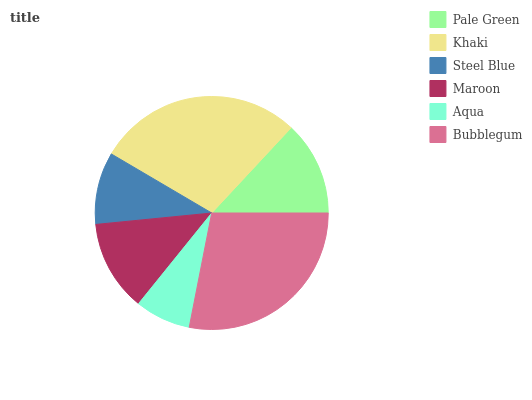Is Aqua the minimum?
Answer yes or no. Yes. Is Khaki the maximum?
Answer yes or no. Yes. Is Steel Blue the minimum?
Answer yes or no. No. Is Steel Blue the maximum?
Answer yes or no. No. Is Khaki greater than Steel Blue?
Answer yes or no. Yes. Is Steel Blue less than Khaki?
Answer yes or no. Yes. Is Steel Blue greater than Khaki?
Answer yes or no. No. Is Khaki less than Steel Blue?
Answer yes or no. No. Is Pale Green the high median?
Answer yes or no. Yes. Is Maroon the low median?
Answer yes or no. Yes. Is Aqua the high median?
Answer yes or no. No. Is Aqua the low median?
Answer yes or no. No. 